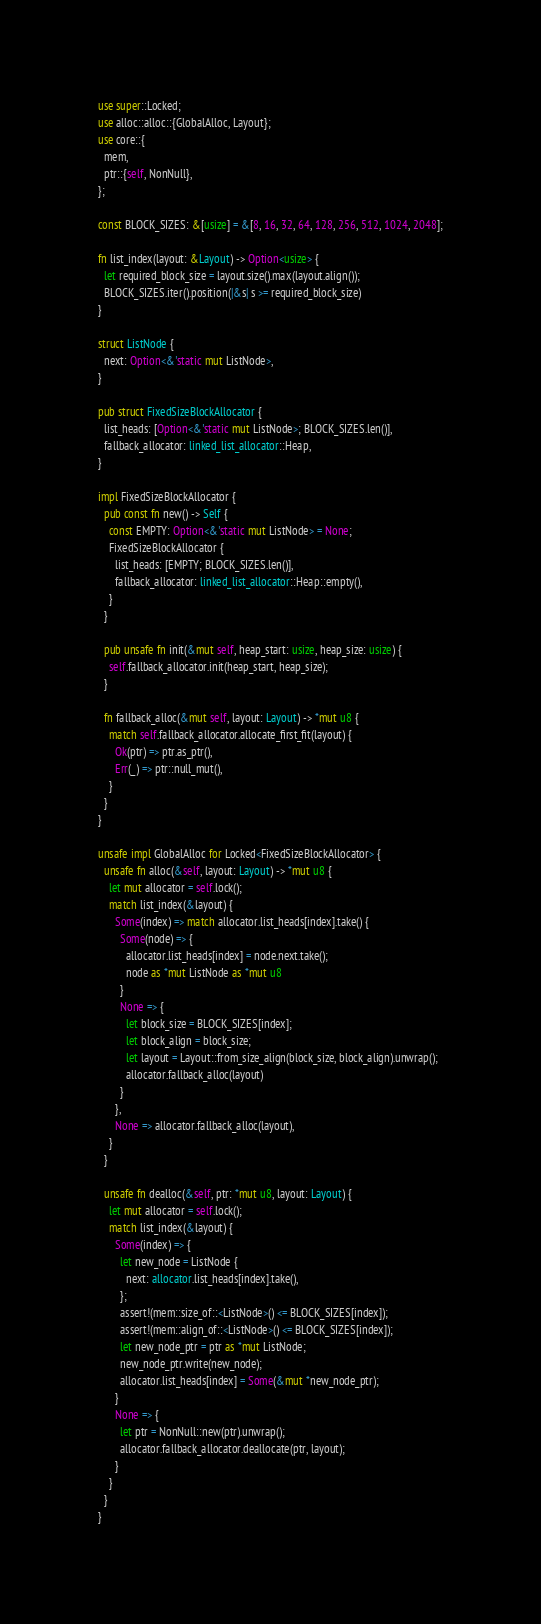<code> <loc_0><loc_0><loc_500><loc_500><_Rust_>use super::Locked;
use alloc::alloc::{GlobalAlloc, Layout};
use core::{
  mem,
  ptr::{self, NonNull},
};

const BLOCK_SIZES: &[usize] = &[8, 16, 32, 64, 128, 256, 512, 1024, 2048];

fn list_index(layout: &Layout) -> Option<usize> {
  let required_block_size = layout.size().max(layout.align());
  BLOCK_SIZES.iter().position(|&s| s >= required_block_size)
}

struct ListNode {
  next: Option<&'static mut ListNode>,
}

pub struct FixedSizeBlockAllocator {
  list_heads: [Option<&'static mut ListNode>; BLOCK_SIZES.len()],
  fallback_allocator: linked_list_allocator::Heap,
}

impl FixedSizeBlockAllocator {
  pub const fn new() -> Self {
    const EMPTY: Option<&'static mut ListNode> = None;
    FixedSizeBlockAllocator {
      list_heads: [EMPTY; BLOCK_SIZES.len()],
      fallback_allocator: linked_list_allocator::Heap::empty(),
    }
  }

  pub unsafe fn init(&mut self, heap_start: usize, heap_size: usize) {
    self.fallback_allocator.init(heap_start, heap_size);
  }

  fn fallback_alloc(&mut self, layout: Layout) -> *mut u8 {
    match self.fallback_allocator.allocate_first_fit(layout) {
      Ok(ptr) => ptr.as_ptr(),
      Err(_) => ptr::null_mut(),
    }
  }
}

unsafe impl GlobalAlloc for Locked<FixedSizeBlockAllocator> {
  unsafe fn alloc(&self, layout: Layout) -> *mut u8 {
    let mut allocator = self.lock();
    match list_index(&layout) {
      Some(index) => match allocator.list_heads[index].take() {
        Some(node) => {
          allocator.list_heads[index] = node.next.take();
          node as *mut ListNode as *mut u8
        }
        None => {
          let block_size = BLOCK_SIZES[index];
          let block_align = block_size;
          let layout = Layout::from_size_align(block_size, block_align).unwrap();
          allocator.fallback_alloc(layout)
        }
      },
      None => allocator.fallback_alloc(layout),
    }
  }

  unsafe fn dealloc(&self, ptr: *mut u8, layout: Layout) {
    let mut allocator = self.lock();
    match list_index(&layout) {
      Some(index) => {
        let new_node = ListNode {
          next: allocator.list_heads[index].take(),
        };
        assert!(mem::size_of::<ListNode>() <= BLOCK_SIZES[index]);
        assert!(mem::align_of::<ListNode>() <= BLOCK_SIZES[index]);
        let new_node_ptr = ptr as *mut ListNode;
        new_node_ptr.write(new_node);
        allocator.list_heads[index] = Some(&mut *new_node_ptr);
      }
      None => {
        let ptr = NonNull::new(ptr).unwrap();
        allocator.fallback_allocator.deallocate(ptr, layout);
      }
    }
  }
}
</code> 